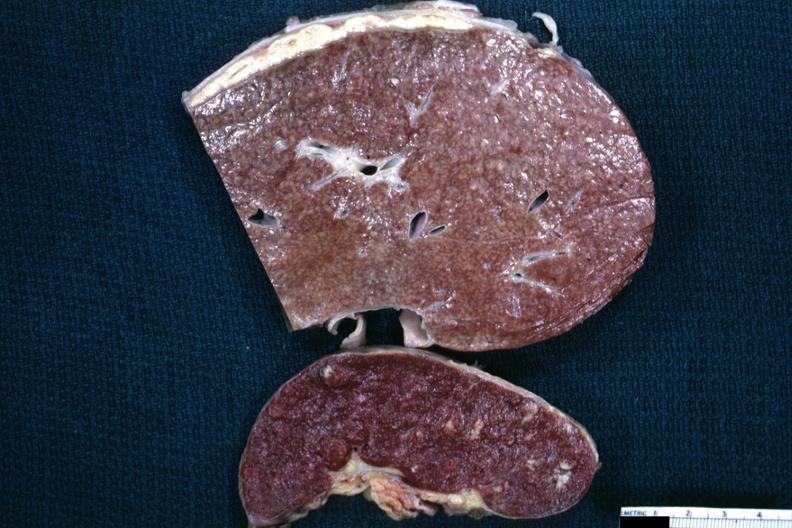what is typical tuberculous exudate of liver and spleen?
Answer the question using a single word or phrase. Present on capsule 